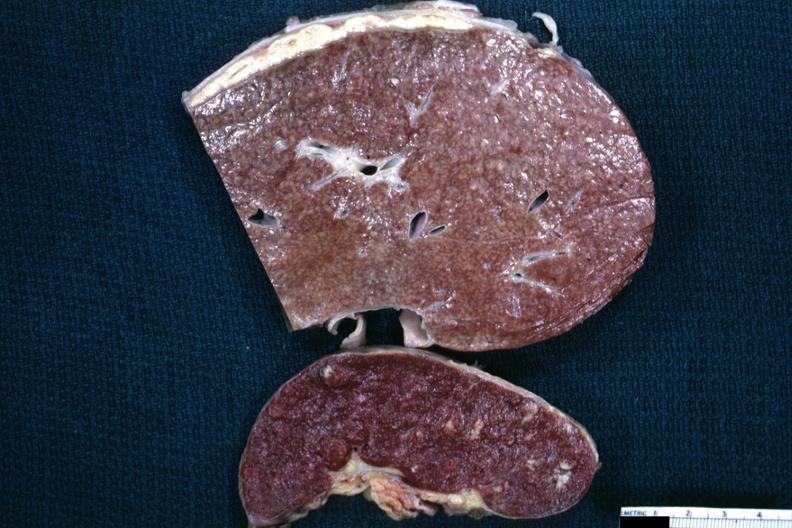what is typical tuberculous exudate of liver and spleen?
Answer the question using a single word or phrase. Present on capsule 